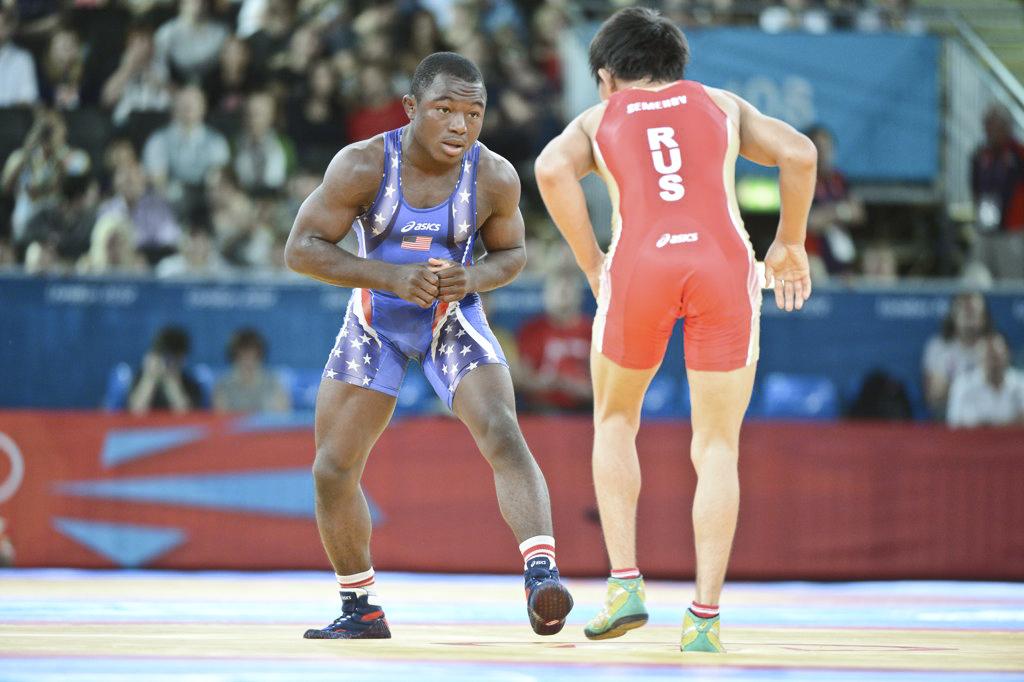What is on the blue jumper?
Make the answer very short. Asics. 